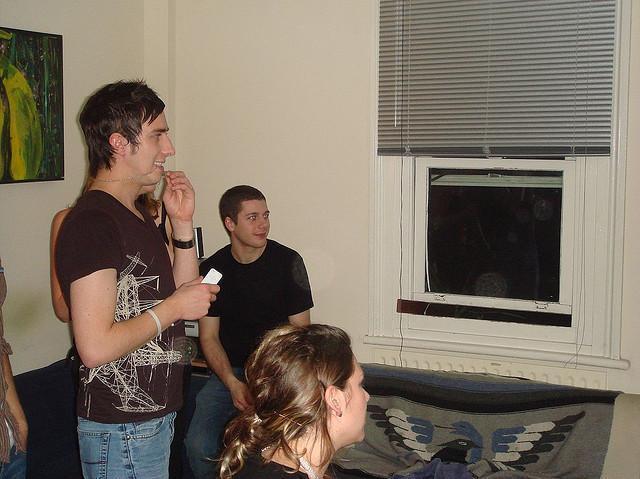How many people are there?
Give a very brief answer. 4. 